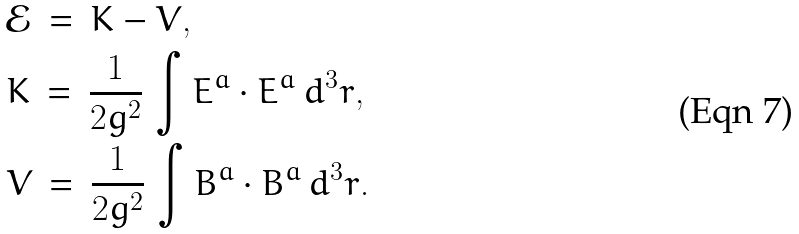Convert formula to latex. <formula><loc_0><loc_0><loc_500><loc_500>& \mathcal { E } \, = \, K - V , \\ & K \, = \, \frac { 1 } { 2 g ^ { 2 } } \, \int E ^ { a } \cdot E ^ { a } \, d ^ { 3 } r , \\ & V \, = \, \frac { 1 } { 2 g ^ { 2 } } \, \int B ^ { a } \cdot B ^ { a } \, d ^ { 3 } r .</formula> 